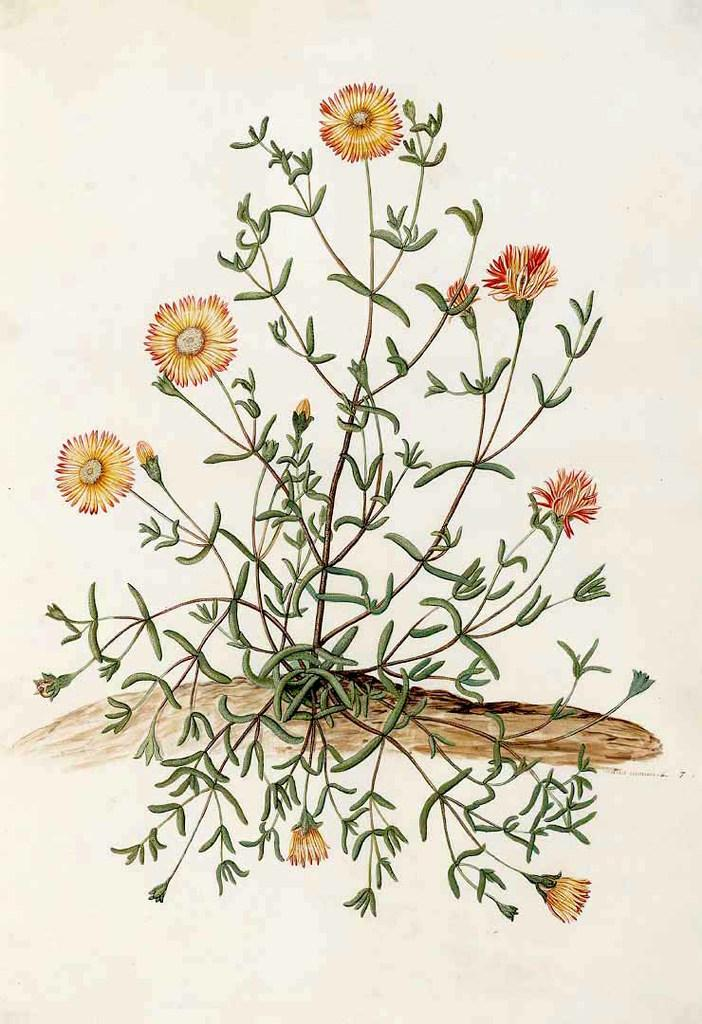What is the main subject of the picture? The main subject of the picture is a printed image of a plant with flowers. What color is the background of the picture? The background of the picture is white. How many pigs are present in the picture? There are no pigs present in the picture; it features a printed image of a plant with flowers against a white background. 